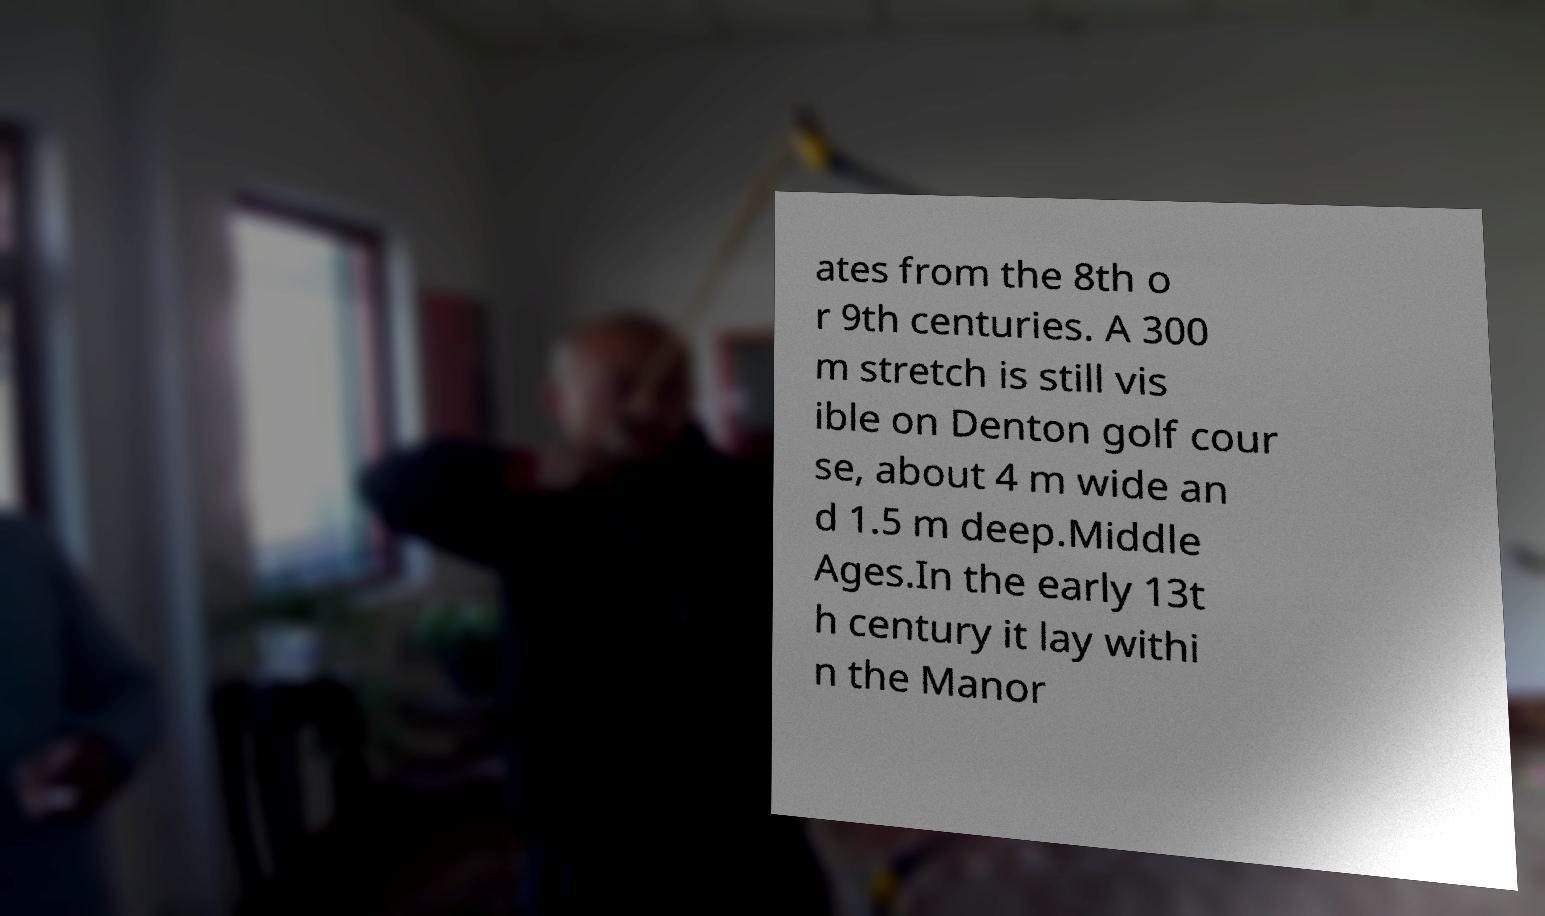What messages or text are displayed in this image? I need them in a readable, typed format. ates from the 8th o r 9th centuries. A 300 m stretch is still vis ible on Denton golf cour se, about 4 m wide an d 1.5 m deep.Middle Ages.In the early 13t h century it lay withi n the Manor 